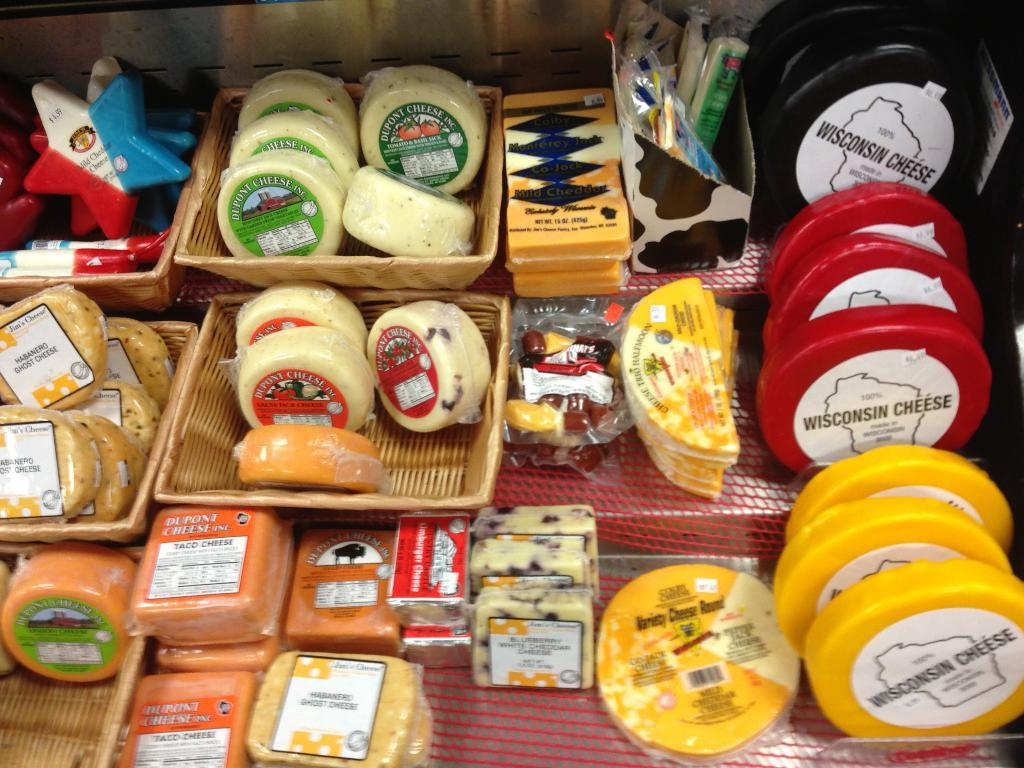Provide a one-sentence caption for the provided image. Several varieties of cheese are on a shelf, including some from Wisconsin. 